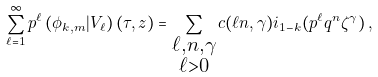Convert formula to latex. <formula><loc_0><loc_0><loc_500><loc_500>\sum _ { \ell = 1 } ^ { \infty } p ^ { \ell } \left ( \phi _ { k , m } | V _ { \ell } \right ) ( \tau , z ) = \sum _ { \substack { \ell , n , \gamma \\ \ell > 0 } } c ( \ell n , \gamma ) \L i _ { 1 - k } ( p ^ { \ell } q ^ { n } \zeta ^ { \gamma } ) \, ,</formula> 